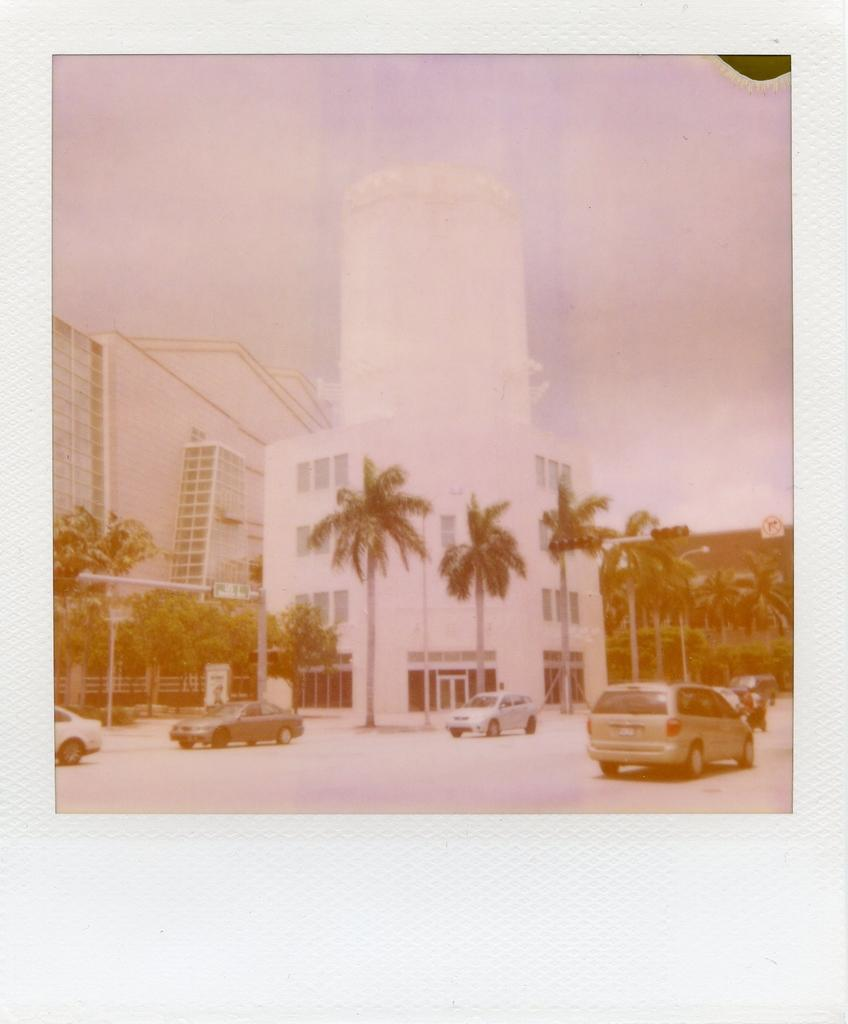What is happening on the road in the image? There are cars moving on the road in the image. What structures can be seen in the image? There are poles, trees, and buildings with windows in the image. What is the condition of the sky in the image? The sky is clear in the image. How many clocks are hanging from the trees in the image? There are no clocks hanging from the trees in the image. What type of business is being conducted in the image? There is no indication of a business being conducted in the image. 